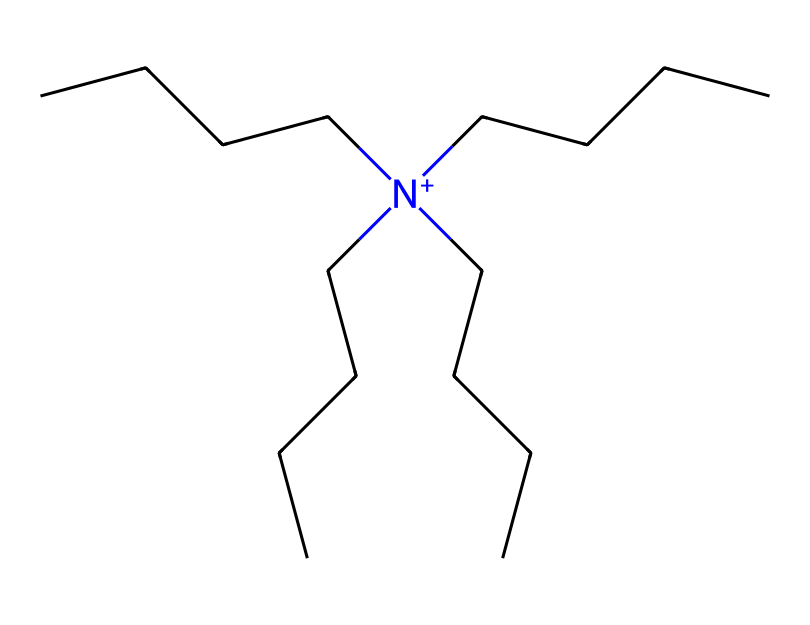What type of compound is represented by this SMILES? The structure contains a nitrogen atom with a positive charge, which indicates it is a quaternary ammonium compound. These compounds are characterized by a central nitrogen atom bonded to four hydrocarbon chains.
Answer: quaternary ammonium compound How many carbon atoms are in the molecular structure? Analyzing the SMILES representation, there are four long hydrocarbon chains, each contributing several carbon atoms. Counting all the carbon atoms in the chains gives us a total of sixteen.
Answer: sixteen What is the molecular charge of this compound? The SMILES notation shows a nitrogen atom with a positive charge denoted by [N+]. This indicates that the overall molecular charge of the compound is positive.
Answer: positive What is the role of this chemical in fabric softeners? Quaternary ammonium compounds are mainly used in fabric softeners to reduce static cling and make fabrics feel softer by coating the fibers with a smooth layer.
Answer: softening agent How many hydrogen atoms are attached to the nitrogen atom in the structure? In quaternary ammonium compounds, the nitrogen atom typically does not have hydrogen atoms attached since it is fully substituted with four carbon chains. Therefore, there are no hydrogen atoms bonded to the nitrogen in this structure.
Answer: zero Which functional group characterizes this class of detergents? The presence of the quaternary ammonium group, denoted by the positively charged nitrogen, characterizes this class of detergents, as it is specifically known for its surfactant properties.
Answer: quaternary ammonium group What is the potential environmental concern related to quaternary ammonium compounds? Quaternary ammonium compounds can be toxic to aquatic life and may contribute to environmental pollution if they are released in large quantities during their use or disposal.
Answer: toxicity to aquatic life 